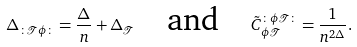Convert formula to latex. <formula><loc_0><loc_0><loc_500><loc_500>\Delta _ { \colon \mathcal { T } \phi \colon } = \frac { \Delta } { n } + \Delta _ { \mathcal { T } } \quad \text {and} \quad \tilde { C } _ { \phi \mathcal { T } } ^ { \colon \phi \mathcal { T } \colon } = \frac { 1 } { n ^ { 2 \Delta } } .</formula> 